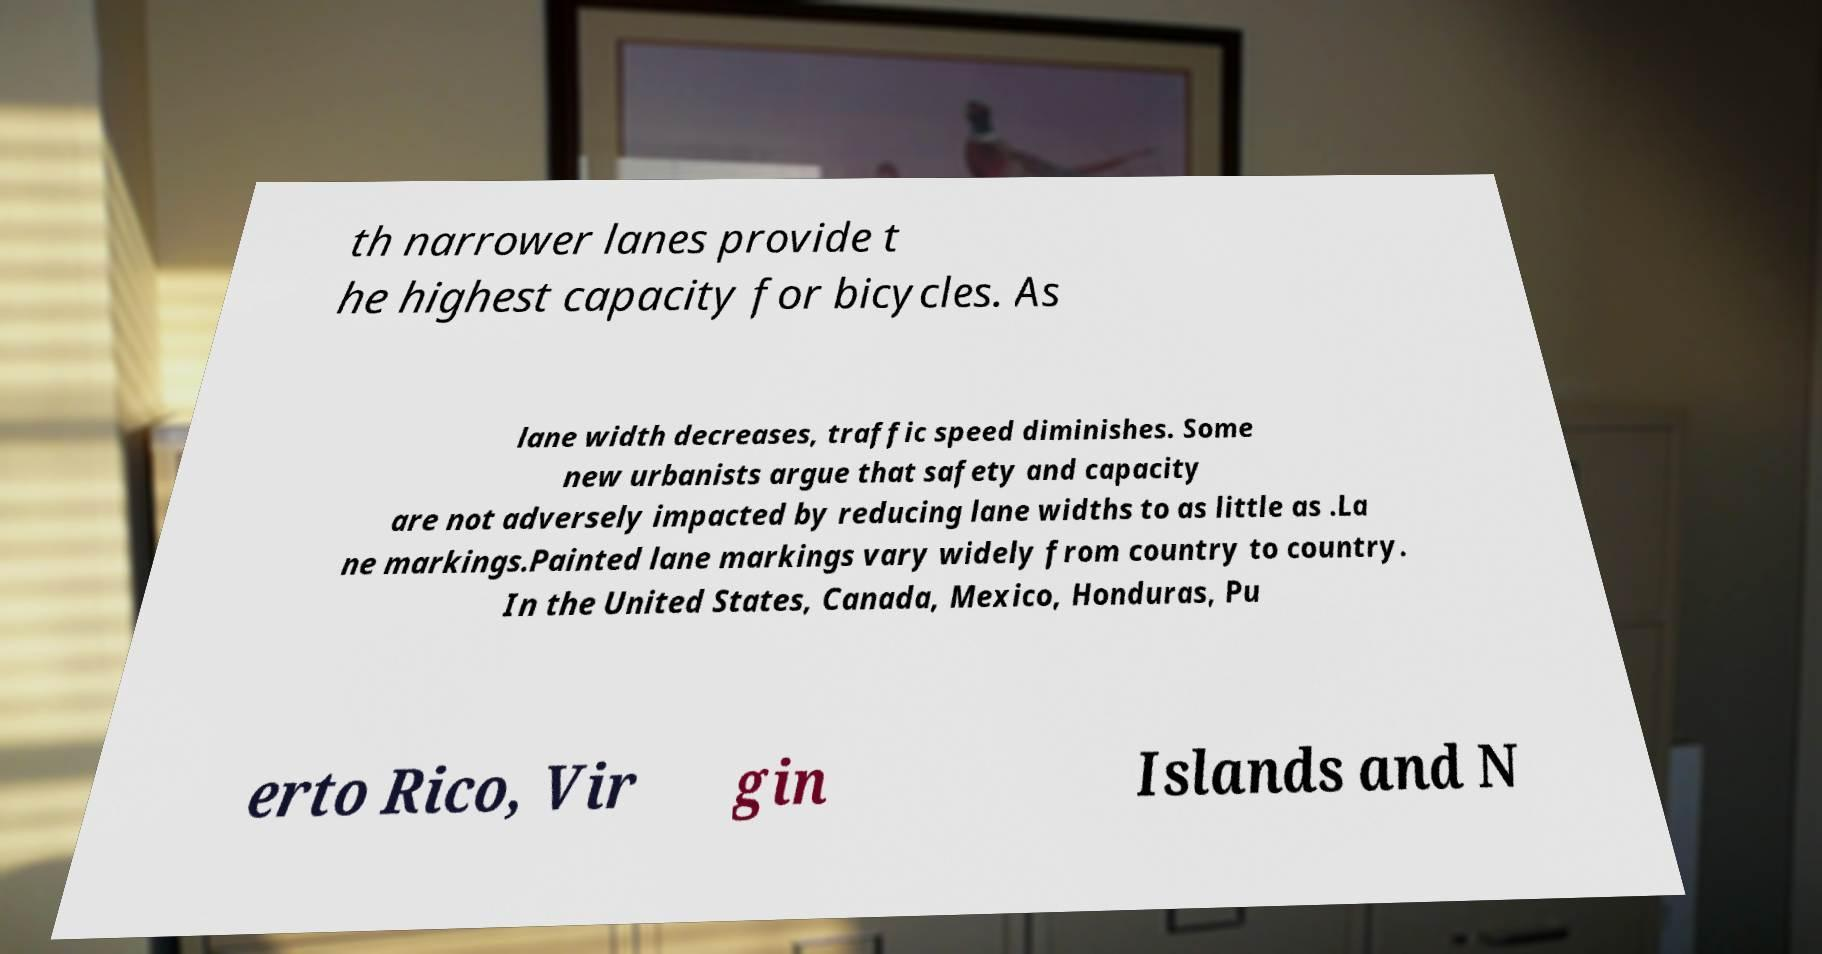Can you accurately transcribe the text from the provided image for me? th narrower lanes provide t he highest capacity for bicycles. As lane width decreases, traffic speed diminishes. Some new urbanists argue that safety and capacity are not adversely impacted by reducing lane widths to as little as .La ne markings.Painted lane markings vary widely from country to country. In the United States, Canada, Mexico, Honduras, Pu erto Rico, Vir gin Islands and N 